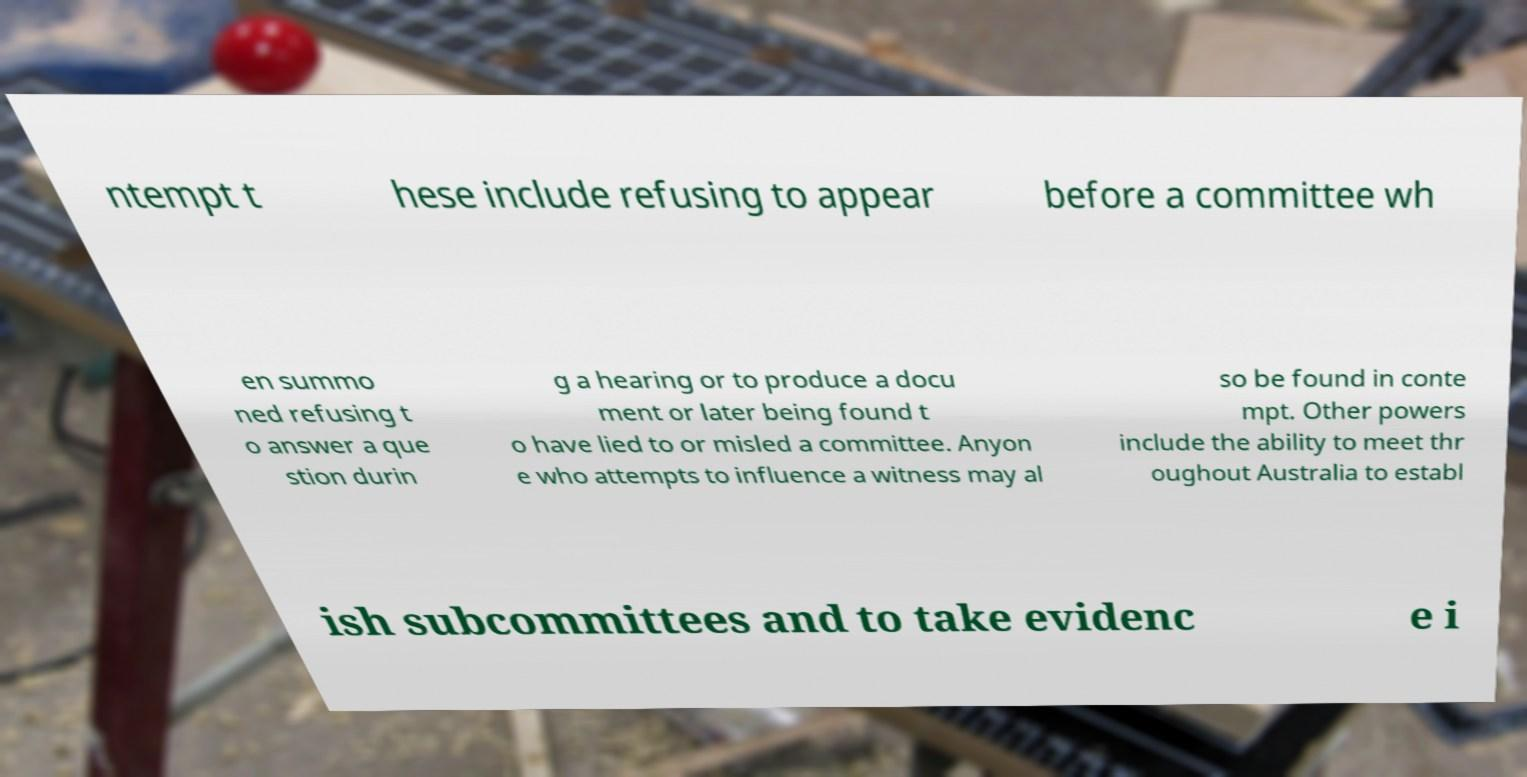What messages or text are displayed in this image? I need them in a readable, typed format. ntempt t hese include refusing to appear before a committee wh en summo ned refusing t o answer a que stion durin g a hearing or to produce a docu ment or later being found t o have lied to or misled a committee. Anyon e who attempts to influence a witness may al so be found in conte mpt. Other powers include the ability to meet thr oughout Australia to establ ish subcommittees and to take evidenc e i 